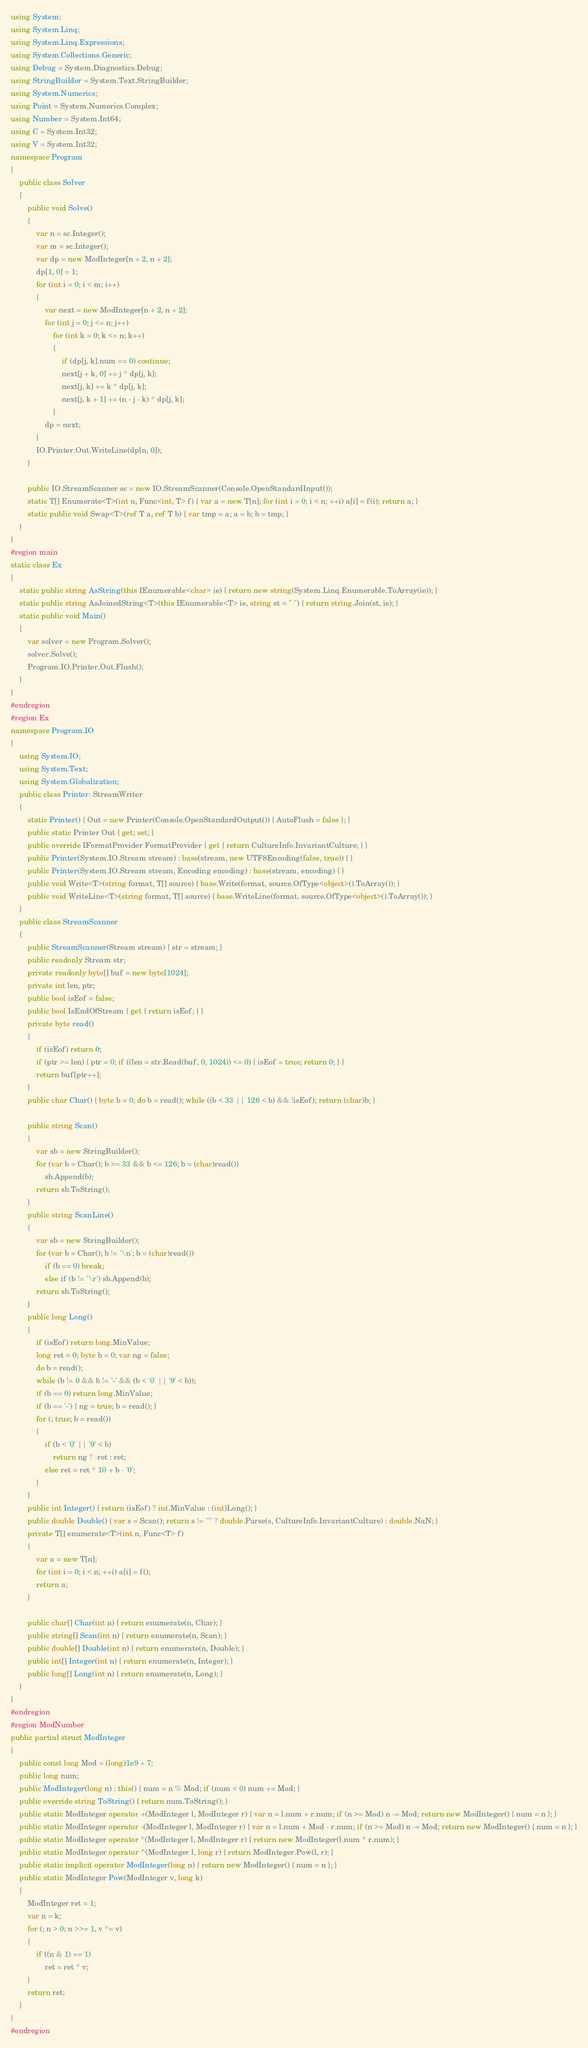<code> <loc_0><loc_0><loc_500><loc_500><_C#_>using System;
using System.Linq;
using System.Linq.Expressions;
using System.Collections.Generic;
using Debug = System.Diagnostics.Debug;
using StringBuilder = System.Text.StringBuilder;
using System.Numerics;
using Point = System.Numerics.Complex;
using Number = System.Int64;
using C = System.Int32;
using V = System.Int32;
namespace Program
{
    public class Solver
    {
        public void Solve()
        {
            var n = sc.Integer();
            var m = sc.Integer();
            var dp = new ModInteger[n + 2, n + 2];
            dp[1, 0] = 1;
            for (int i = 0; i < m; i++)
            {
                var next = new ModInteger[n + 2, n + 2];
                for (int j = 0; j <= n; j++)
                    for (int k = 0; k <= n; k++)
                    {
                        if (dp[j, k].num == 0) continue;
                        next[j + k, 0] += j * dp[j, k];
                        next[j, k] += k * dp[j, k];
                        next[j, k + 1] += (n - j - k) * dp[j, k];
                    }
                dp = next;
            }
            IO.Printer.Out.WriteLine(dp[n, 0]);
        }

        public IO.StreamScanner sc = new IO.StreamScanner(Console.OpenStandardInput());
        static T[] Enumerate<T>(int n, Func<int, T> f) { var a = new T[n]; for (int i = 0; i < n; ++i) a[i] = f(i); return a; }
        static public void Swap<T>(ref T a, ref T b) { var tmp = a; a = b; b = tmp; }
    }
}
#region main
static class Ex
{
    static public string AsString(this IEnumerable<char> ie) { return new string(System.Linq.Enumerable.ToArray(ie)); }
    static public string AsJoinedString<T>(this IEnumerable<T> ie, string st = " ") { return string.Join(st, ie); }
    static public void Main()
    {
        var solver = new Program.Solver();
        solver.Solve();
        Program.IO.Printer.Out.Flush();
    }
}
#endregion
#region Ex
namespace Program.IO
{
    using System.IO;
    using System.Text;
    using System.Globalization;
    public class Printer: StreamWriter
    {
        static Printer() { Out = new Printer(Console.OpenStandardOutput()) { AutoFlush = false }; }
        public static Printer Out { get; set; }
        public override IFormatProvider FormatProvider { get { return CultureInfo.InvariantCulture; } }
        public Printer(System.IO.Stream stream) : base(stream, new UTF8Encoding(false, true)) { }
        public Printer(System.IO.Stream stream, Encoding encoding) : base(stream, encoding) { }
        public void Write<T>(string format, T[] source) { base.Write(format, source.OfType<object>().ToArray()); }
        public void WriteLine<T>(string format, T[] source) { base.WriteLine(format, source.OfType<object>().ToArray()); }
    }
    public class StreamScanner
    {
        public StreamScanner(Stream stream) { str = stream; }
        public readonly Stream str;
        private readonly byte[] buf = new byte[1024];
        private int len, ptr;
        public bool isEof = false;
        public bool IsEndOfStream { get { return isEof; } }
        private byte read()
        {
            if (isEof) return 0;
            if (ptr >= len) { ptr = 0; if ((len = str.Read(buf, 0, 1024)) <= 0) { isEof = true; return 0; } }
            return buf[ptr++];
        }
        public char Char() { byte b = 0; do b = read(); while ((b < 33 || 126 < b) && !isEof); return (char)b; }

        public string Scan()
        {
            var sb = new StringBuilder();
            for (var b = Char(); b >= 33 && b <= 126; b = (char)read())
                sb.Append(b);
            return sb.ToString();
        }
        public string ScanLine()
        {
            var sb = new StringBuilder();
            for (var b = Char(); b != '\n'; b = (char)read())
                if (b == 0) break;
                else if (b != '\r') sb.Append(b);
            return sb.ToString();
        }
        public long Long()
        {
            if (isEof) return long.MinValue;
            long ret = 0; byte b = 0; var ng = false;
            do b = read();
            while (b != 0 && b != '-' && (b < '0' || '9' < b));
            if (b == 0) return long.MinValue;
            if (b == '-') { ng = true; b = read(); }
            for (; true; b = read())
            {
                if (b < '0' || '9' < b)
                    return ng ? -ret : ret;
                else ret = ret * 10 + b - '0';
            }
        }
        public int Integer() { return (isEof) ? int.MinValue : (int)Long(); }
        public double Double() { var s = Scan(); return s != "" ? double.Parse(s, CultureInfo.InvariantCulture) : double.NaN; }
        private T[] enumerate<T>(int n, Func<T> f)
        {
            var a = new T[n];
            for (int i = 0; i < n; ++i) a[i] = f();
            return a;
        }

        public char[] Char(int n) { return enumerate(n, Char); }
        public string[] Scan(int n) { return enumerate(n, Scan); }
        public double[] Double(int n) { return enumerate(n, Double); }
        public int[] Integer(int n) { return enumerate(n, Integer); }
        public long[] Long(int n) { return enumerate(n, Long); }
    }
}
#endregion
#region ModNumber
public partial struct ModInteger
{
    public const long Mod = (long)1e9 + 7;
    public long num;
    public ModInteger(long n) : this() { num = n % Mod; if (num < 0) num += Mod; }
    public override string ToString() { return num.ToString(); }
    public static ModInteger operator +(ModInteger l, ModInteger r) { var n = l.num + r.num; if (n >= Mod) n -= Mod; return new ModInteger() { num = n }; }
    public static ModInteger operator -(ModInteger l, ModInteger r) { var n = l.num + Mod - r.num; if (n >= Mod) n -= Mod; return new ModInteger() { num = n }; }
    public static ModInteger operator *(ModInteger l, ModInteger r) { return new ModInteger(l.num * r.num); }
    public static ModInteger operator ^(ModInteger l, long r) { return ModInteger.Pow(l, r); }
    public static implicit operator ModInteger(long n) { return new ModInteger() { num = n }; }
    public static ModInteger Pow(ModInteger v, long k)
    {
        ModInteger ret = 1;
        var n = k;
        for (; n > 0; n >>= 1, v *= v)
        {
            if ((n & 1) == 1)
                ret = ret * v;
        }
        return ret;
    }
}
#endregion</code> 